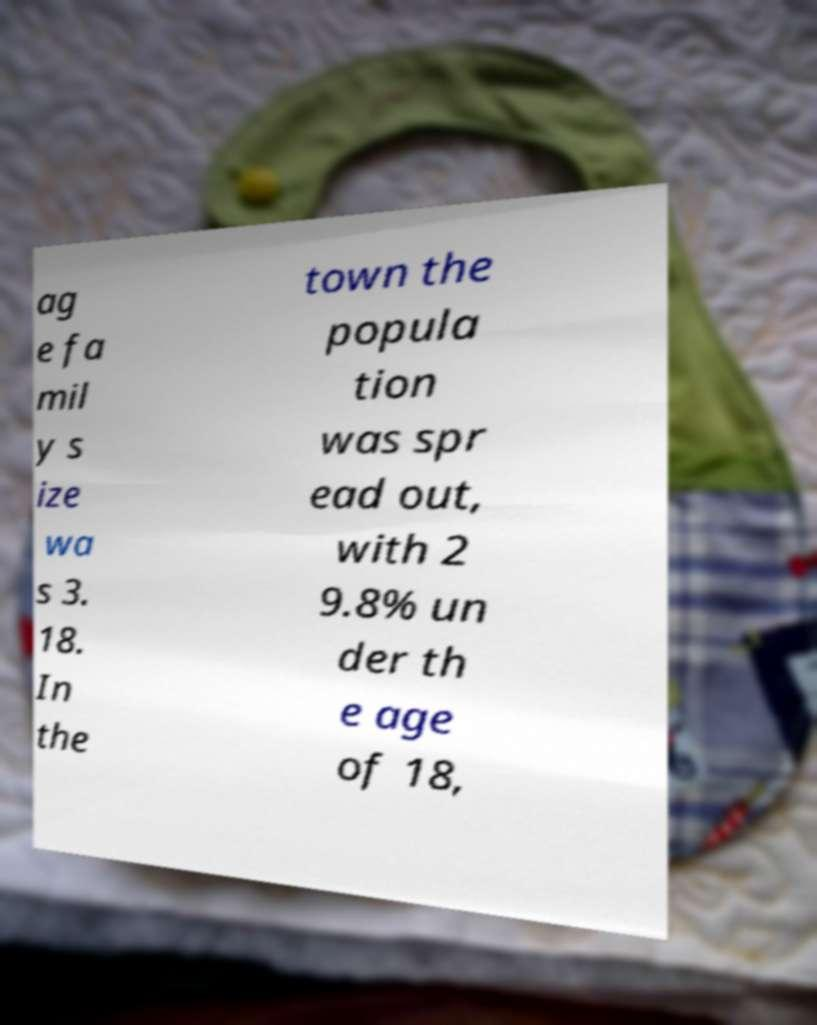For documentation purposes, I need the text within this image transcribed. Could you provide that? ag e fa mil y s ize wa s 3. 18. In the town the popula tion was spr ead out, with 2 9.8% un der th e age of 18, 